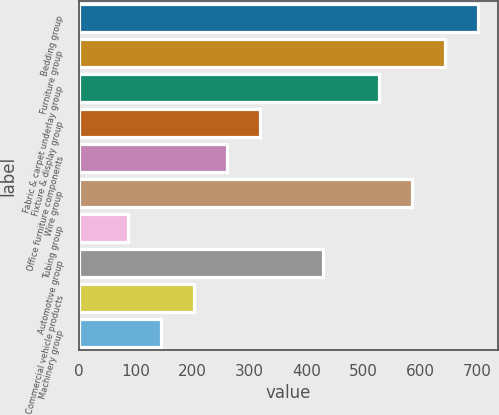<chart> <loc_0><loc_0><loc_500><loc_500><bar_chart><fcel>Bedding group<fcel>Furniture group<fcel>Fabric & carpet underlay group<fcel>Fixture & display group<fcel>Office furniture components<fcel>Wire group<fcel>Tubing group<fcel>Automotive group<fcel>Commercial vehicle products<fcel>Machinery group<nl><fcel>701.09<fcel>643.06<fcel>527<fcel>319.02<fcel>260.99<fcel>585.03<fcel>86.9<fcel>428.7<fcel>202.96<fcel>144.93<nl></chart> 